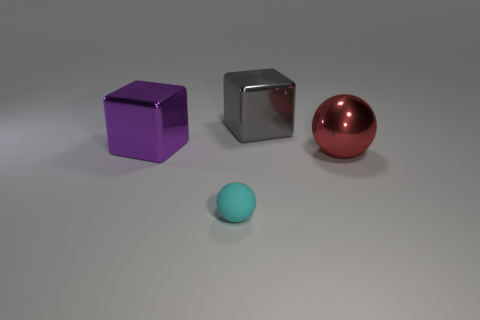Add 3 purple metallic objects. How many objects exist? 7 Subtract 0 cyan cubes. How many objects are left? 4 Subtract all large red metallic things. Subtract all tiny brown matte cubes. How many objects are left? 3 Add 3 gray shiny things. How many gray shiny things are left? 4 Add 4 tiny objects. How many tiny objects exist? 5 